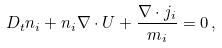<formula> <loc_0><loc_0><loc_500><loc_500>D _ { t } n _ { i } + n _ { i } \nabla \cdot { U } + \frac { \nabla \cdot { j } _ { i } } { m _ { i } } = 0 \, ,</formula> 